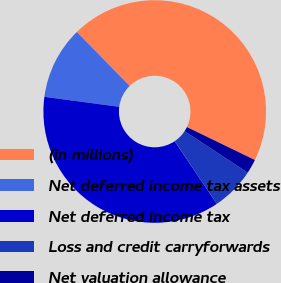Convert chart. <chart><loc_0><loc_0><loc_500><loc_500><pie_chart><fcel>(in millions)<fcel>Net deferred income tax assets<fcel>Net deferred income tax<fcel>Loss and credit carryforwards<fcel>Net valuation allowance<nl><fcel>44.51%<fcel>10.56%<fcel>36.53%<fcel>6.32%<fcel>2.08%<nl></chart> 